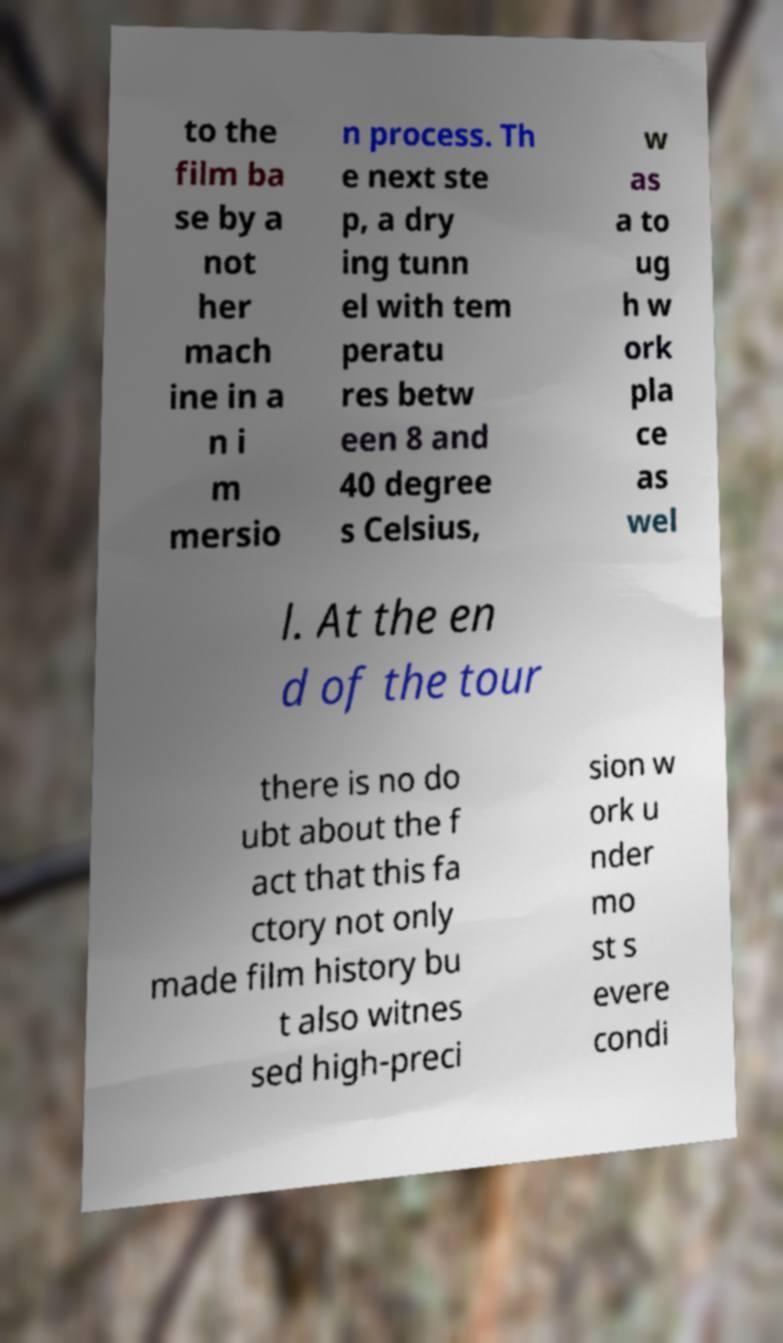Please read and relay the text visible in this image. What does it say? to the film ba se by a not her mach ine in a n i m mersio n process. Th e next ste p, a dry ing tunn el with tem peratu res betw een 8 and 40 degree s Celsius, w as a to ug h w ork pla ce as wel l. At the en d of the tour there is no do ubt about the f act that this fa ctory not only made film history bu t also witnes sed high-preci sion w ork u nder mo st s evere condi 